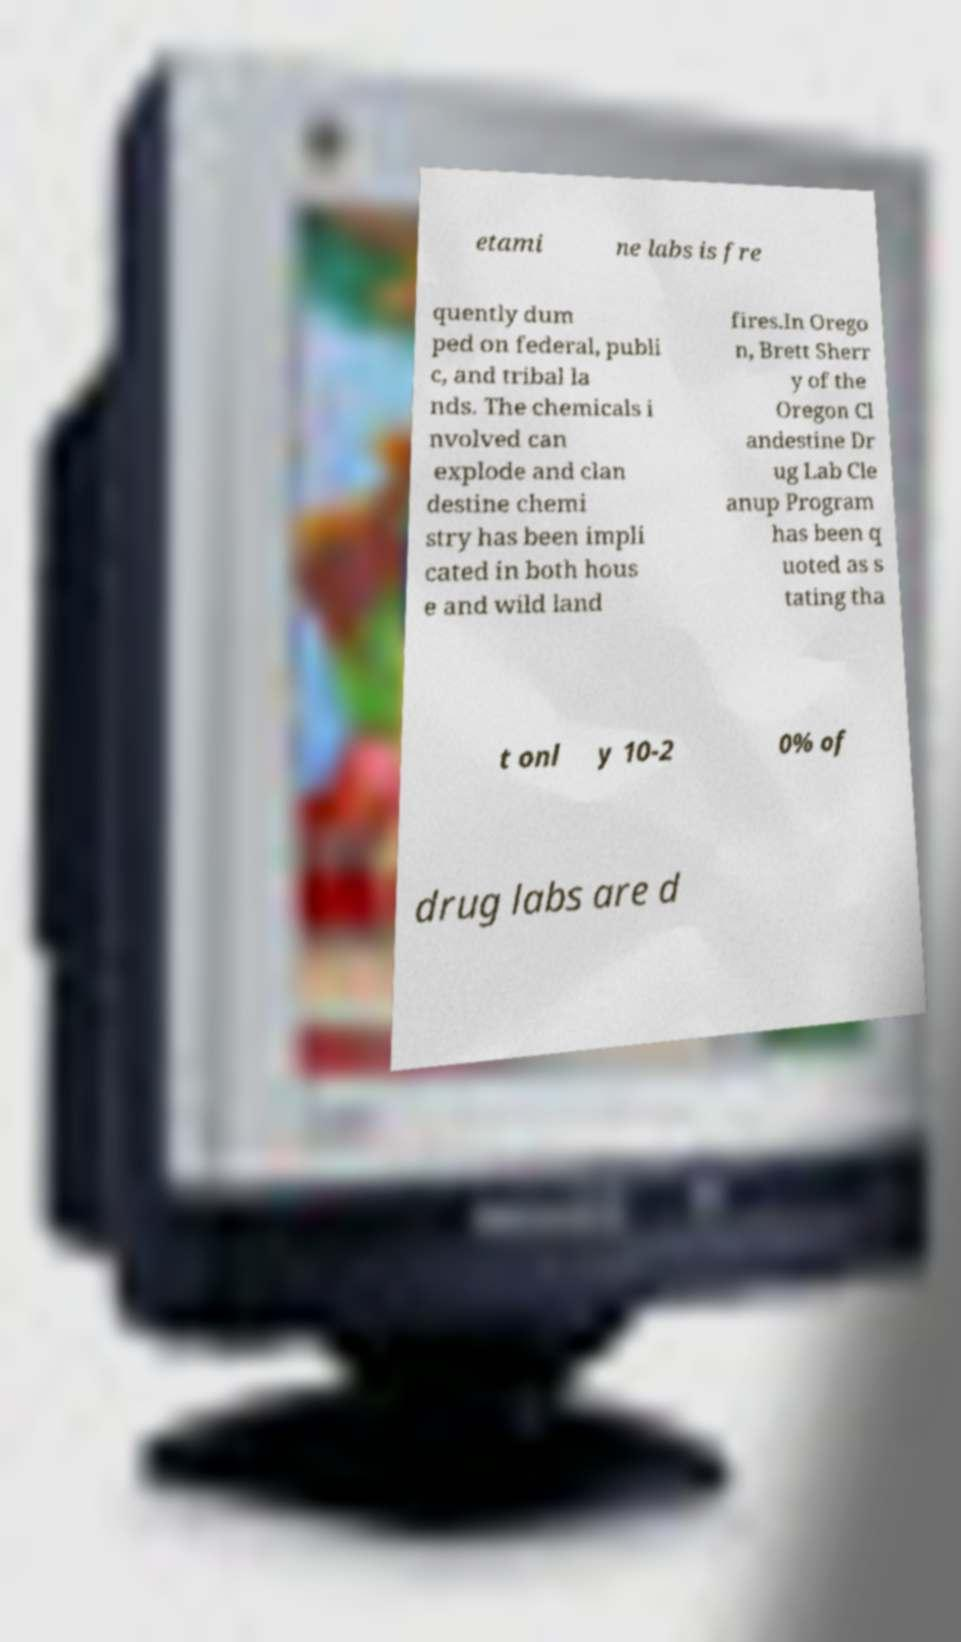Could you extract and type out the text from this image? etami ne labs is fre quently dum ped on federal, publi c, and tribal la nds. The chemicals i nvolved can explode and clan destine chemi stry has been impli cated in both hous e and wild land fires.In Orego n, Brett Sherr y of the Oregon Cl andestine Dr ug Lab Cle anup Program has been q uoted as s tating tha t onl y 10-2 0% of drug labs are d 